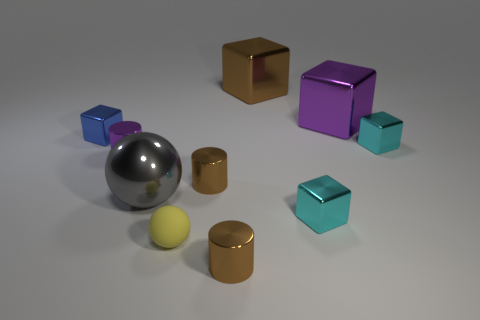There is a cylinder that is on the right side of the gray shiny object and behind the gray sphere; what is its color?
Provide a short and direct response. Brown. How many metallic cylinders are the same size as the purple cube?
Keep it short and to the point. 0. There is a thing that is in front of the small purple shiny thing and to the left of the yellow sphere; how big is it?
Offer a terse response. Large. How many tiny blue metallic cubes are to the right of the tiny cylinder that is to the right of the small brown metal object that is behind the small matte object?
Provide a succinct answer. 0. Are there any small matte things that have the same color as the tiny sphere?
Offer a very short reply. No. What color is the matte ball that is the same size as the blue block?
Your answer should be compact. Yellow. The tiny cyan metal thing that is in front of the cyan block that is behind the purple metal thing that is in front of the tiny blue metal object is what shape?
Give a very brief answer. Cube. There is a cyan metal object in front of the tiny purple thing; what number of large purple metallic blocks are left of it?
Your answer should be very brief. 0. Does the purple shiny object that is to the right of the small yellow rubber sphere have the same shape as the purple shiny thing that is to the left of the big gray thing?
Offer a very short reply. No. How many big brown things are behind the tiny purple metal cylinder?
Your answer should be very brief. 1. 